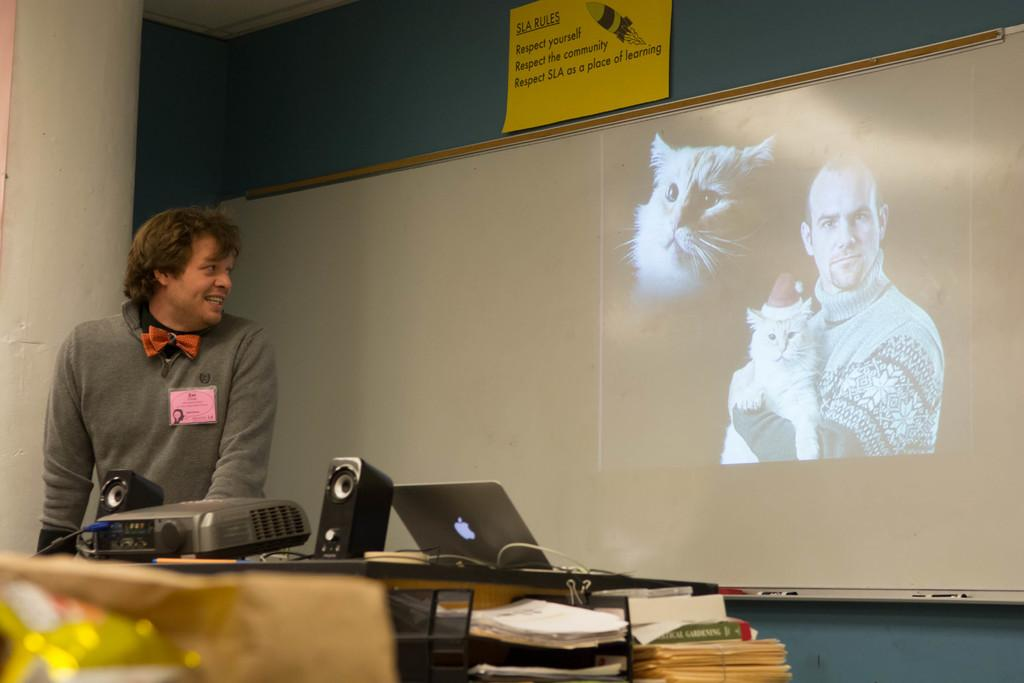<image>
Create a compact narrative representing the image presented. A man is looking at a projector screen that shows a man holding a cat under a yellow sign that says SLA Rules. 